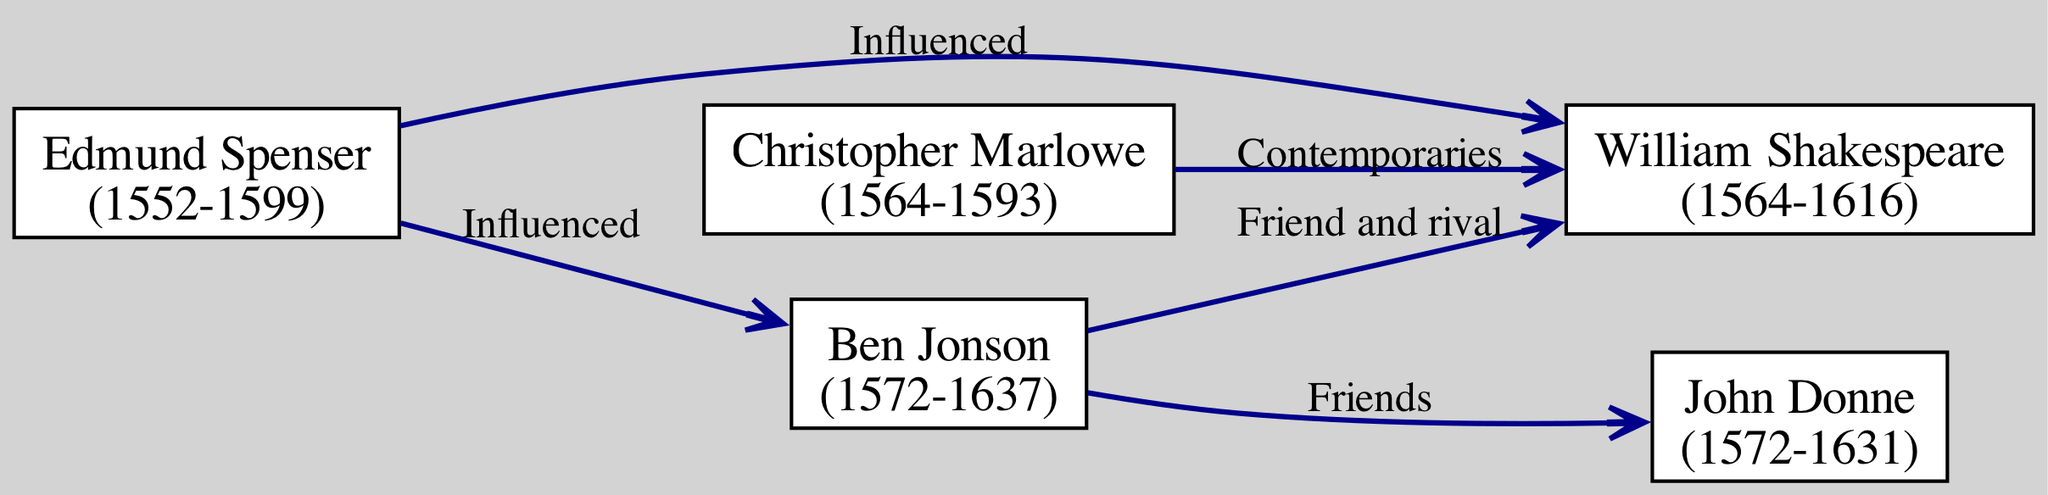What is the birth year of Christopher Marlowe? The diagram indicates that Christopher Marlowe was born in the year 1564, as stated in the corresponding node.
Answer: 1564 Who influenced Ben Jonson? Referring to the connections in the diagram, Edmund Spenser is shown to have influenced Ben Jonson, as indicated by the edge labeled "Influenced."
Answer: Edmund Spenser How many authors are depicted in the diagram? By counting the nodes in the diagram representing the authors, we identify a total of five distinct authors.
Answer: 5 What is the relationship between Ben Jonson and John Donne? The diagram shows an edge between Ben Jonson and John Donne, labeled "Friends," which represents their relationship.
Answer: Friends Which author is contemporaneous with William Shakespeare? Looking at the connections, Christopher Marlowe is specifically mentioned as a contemporary of William Shakespeare in the diagram.
Answer: Christopher Marlowe Which author was born in 1572? The diagram indicates that both Ben Jonson and John Donne were born in the year 1572, as noted in their respective nodes.
Answer: Ben Jonson, John Donne How many connections are shown in the diagram? By examining the edges that connect the authors, we find a total of five distinct connections listed in the diagram.
Answer: 5 Who is shown to have been influenced by Edmund Spenser? From the connections in the diagram, it is evident that William Shakespeare is indicated to have been influenced by Edmund Spenser.
Answer: William Shakespeare What is the death year of John Donne? The diagram illustrates that John Donne died in the year 1631, as indicated in the node containing his information.
Answer: 1631 